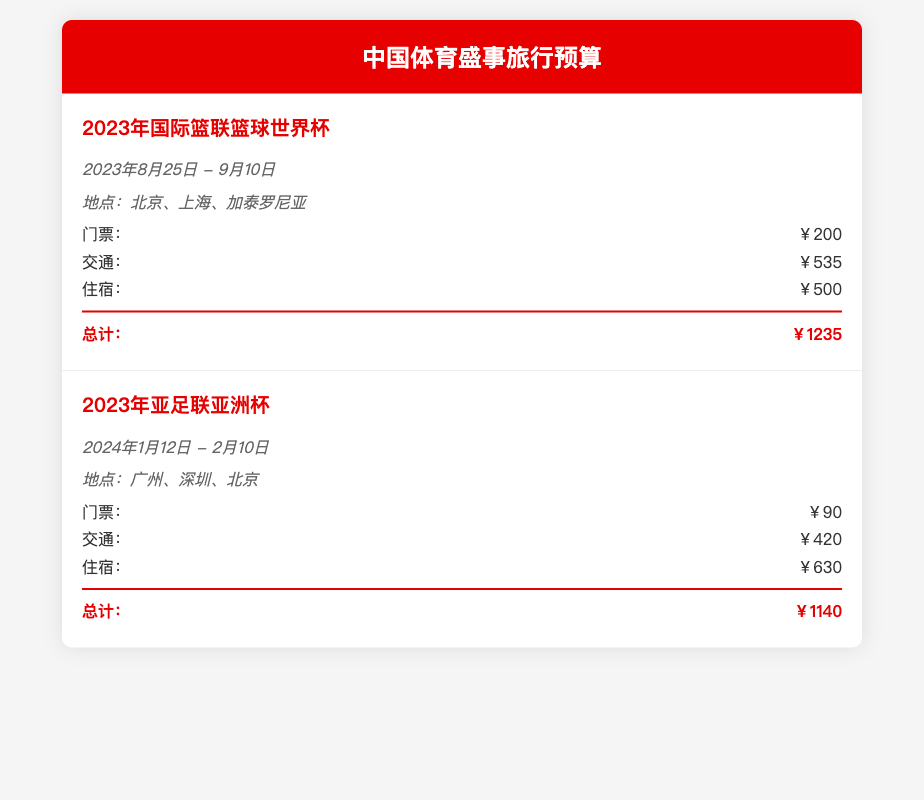什么是2023年国际篮联篮球世界杯的日期？ 日期为2023年8月25日至9月10日。
Answer: 2023年8月25日至9月10日。 2023年亚足联亚洲杯的总费用是多少？ 总费用为门票、交通和住宿的总和，具体为￥90 + ￥420 + ￥630 = ￥1140。
Answer: ￥1140。 2023年国际篮联篮球世界杯的门票价格是多少？ 门票价格在预算项中列出，具体为￥200。
Answer: ￥200。 2023年亚足联亚洲杯的举办城市有哪些？ 预算中列出了该赛事的举办城市，分别为广州、深圳和北京。
Answer: 广州、深圳、北京。 国际篮联篮球世界杯的交通费用是多少？ 预算中列出了交通费用为￥535。
Answer: ￥535。 在预算中，哪个活动的住宿费用最高？ 通过比较两个活动的住宿费用可以得出，亚足联亚洲杯的住宿费用￥630高于篮球世界杯的￥500。
Answer: 亚足联亚洲杯。 哪个活动的总费用低于￥1200？ 通过查看两项赛事的总费用，发现2023年国际篮联篮球世界杯的总费用为￥1235，高于￥1200，而亚足联亚洲杯的总费用为￥1140，低于￥1200。
Answer: 2023年亚足联亚洲杯。 2023年国际篮联篮球世界杯的地点包括哪些城市？ 比较预算中的城市信息，列出该赛事的地点为北京、上海和加泰罗尼亚。
Answer: 北京、上海、加泰罗尼亚。 2024年亚足联亚洲杯的开始日期是什么？ 开始日期为预算中列出的2024年1月12日。
Answer: 2024年1月12日。 